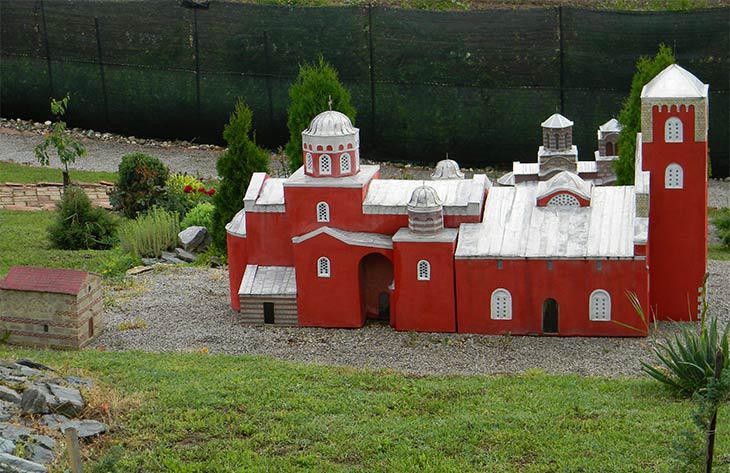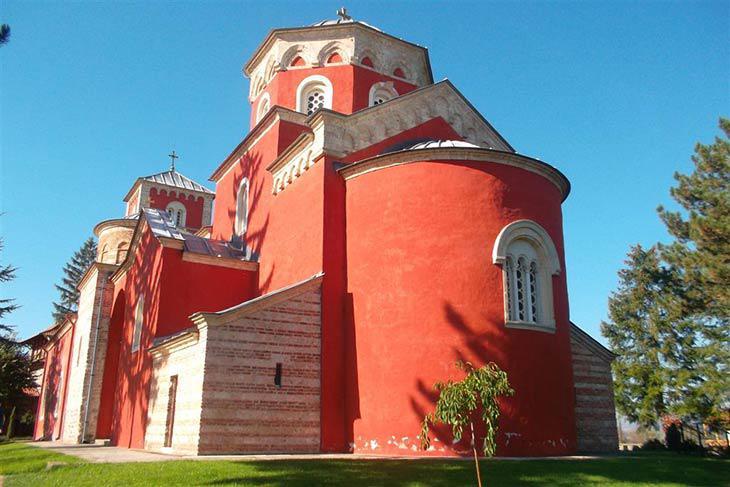The first image is the image on the left, the second image is the image on the right. Given the left and right images, does the statement "One of the images shows a long narrow paved path leading to an orange building with a cross atop." hold true? Answer yes or no. No. The first image is the image on the left, the second image is the image on the right. For the images shown, is this caption "Both images show a sprawling red-orange building with at least one cross-topped dome roof and multiple arch windows." true? Answer yes or no. Yes. 